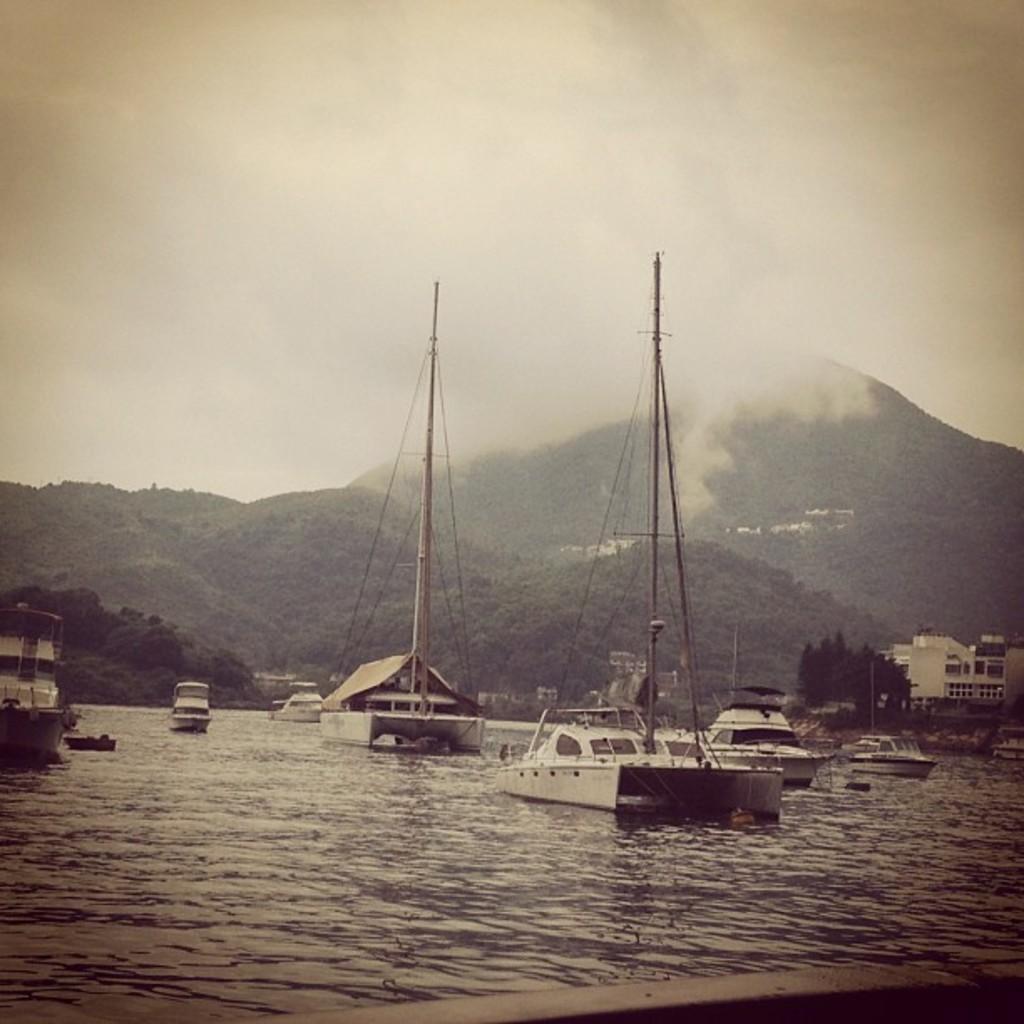Could you give a brief overview of what you see in this image? There is water. On the water there are many boats with poles. On the right side there is building and trees. In the back there are hills and sky with clouds. 